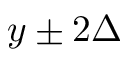<formula> <loc_0><loc_0><loc_500><loc_500>y \pm 2 \Delta</formula> 